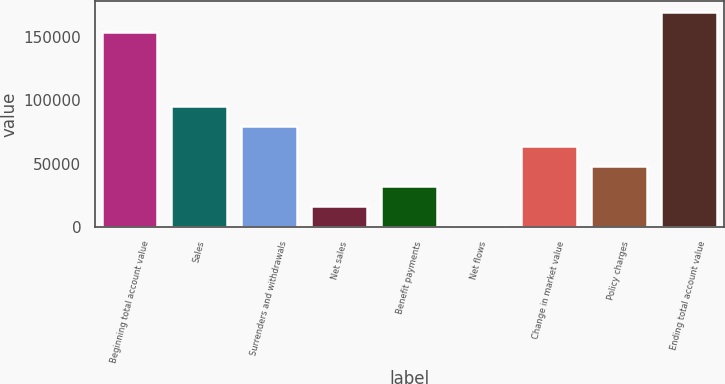Convert chart to OTSL. <chart><loc_0><loc_0><loc_500><loc_500><bar_chart><fcel>Beginning total account value<fcel>Sales<fcel>Surrenders and withdrawals<fcel>Net sales<fcel>Benefit payments<fcel>Net flows<fcel>Change in market value<fcel>Policy charges<fcel>Ending total account value<nl><fcel>154140<fcel>95455.6<fcel>79653.5<fcel>16445.1<fcel>32247.2<fcel>643<fcel>63851.4<fcel>48049.3<fcel>169942<nl></chart> 